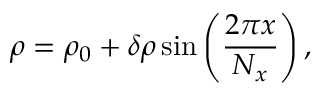Convert formula to latex. <formula><loc_0><loc_0><loc_500><loc_500>\rho = \rho _ { 0 } + \delta \rho \sin \left ( \frac { 2 \pi x } { N _ { x } } \right ) ,</formula> 